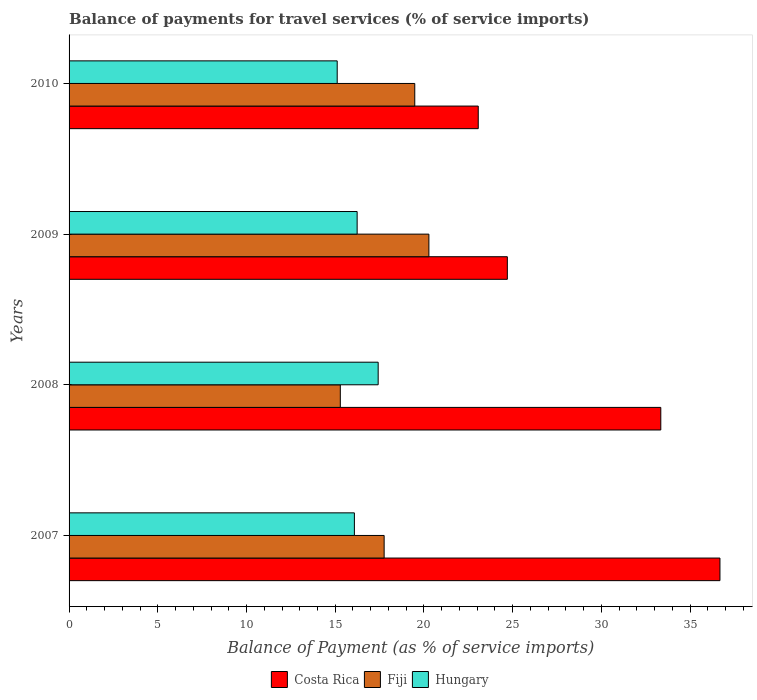How many different coloured bars are there?
Offer a terse response. 3. How many groups of bars are there?
Provide a short and direct response. 4. Are the number of bars per tick equal to the number of legend labels?
Your answer should be compact. Yes. How many bars are there on the 2nd tick from the top?
Make the answer very short. 3. How many bars are there on the 3rd tick from the bottom?
Give a very brief answer. 3. What is the balance of payments for travel services in Hungary in 2007?
Offer a very short reply. 16.08. Across all years, what is the maximum balance of payments for travel services in Fiji?
Ensure brevity in your answer.  20.28. Across all years, what is the minimum balance of payments for travel services in Fiji?
Offer a terse response. 15.29. In which year was the balance of payments for travel services in Fiji maximum?
Offer a terse response. 2009. What is the total balance of payments for travel services in Fiji in the graph?
Offer a very short reply. 72.8. What is the difference between the balance of payments for travel services in Fiji in 2009 and that in 2010?
Your response must be concise. 0.8. What is the difference between the balance of payments for travel services in Hungary in 2009 and the balance of payments for travel services in Costa Rica in 2007?
Make the answer very short. -20.45. What is the average balance of payments for travel services in Costa Rica per year?
Give a very brief answer. 29.45. In the year 2010, what is the difference between the balance of payments for travel services in Hungary and balance of payments for travel services in Fiji?
Your answer should be very brief. -4.37. What is the ratio of the balance of payments for travel services in Costa Rica in 2007 to that in 2010?
Provide a succinct answer. 1.59. Is the balance of payments for travel services in Fiji in 2007 less than that in 2010?
Ensure brevity in your answer.  Yes. Is the difference between the balance of payments for travel services in Hungary in 2008 and 2010 greater than the difference between the balance of payments for travel services in Fiji in 2008 and 2010?
Make the answer very short. Yes. What is the difference between the highest and the second highest balance of payments for travel services in Fiji?
Provide a short and direct response. 0.8. What is the difference between the highest and the lowest balance of payments for travel services in Costa Rica?
Give a very brief answer. 13.62. Is the sum of the balance of payments for travel services in Fiji in 2007 and 2009 greater than the maximum balance of payments for travel services in Hungary across all years?
Provide a succinct answer. Yes. What does the 1st bar from the top in 2008 represents?
Offer a terse response. Hungary. Is it the case that in every year, the sum of the balance of payments for travel services in Fiji and balance of payments for travel services in Hungary is greater than the balance of payments for travel services in Costa Rica?
Keep it short and to the point. No. How many bars are there?
Ensure brevity in your answer.  12. What is the difference between two consecutive major ticks on the X-axis?
Give a very brief answer. 5. Are the values on the major ticks of X-axis written in scientific E-notation?
Offer a terse response. No. Where does the legend appear in the graph?
Offer a very short reply. Bottom center. What is the title of the graph?
Keep it short and to the point. Balance of payments for travel services (% of service imports). What is the label or title of the X-axis?
Your answer should be very brief. Balance of Payment (as % of service imports). What is the label or title of the Y-axis?
Give a very brief answer. Years. What is the Balance of Payment (as % of service imports) of Costa Rica in 2007?
Your answer should be very brief. 36.68. What is the Balance of Payment (as % of service imports) in Fiji in 2007?
Provide a short and direct response. 17.76. What is the Balance of Payment (as % of service imports) in Hungary in 2007?
Offer a terse response. 16.08. What is the Balance of Payment (as % of service imports) in Costa Rica in 2008?
Give a very brief answer. 33.35. What is the Balance of Payment (as % of service imports) in Fiji in 2008?
Keep it short and to the point. 15.29. What is the Balance of Payment (as % of service imports) of Hungary in 2008?
Your answer should be compact. 17.42. What is the Balance of Payment (as % of service imports) in Costa Rica in 2009?
Keep it short and to the point. 24.7. What is the Balance of Payment (as % of service imports) of Fiji in 2009?
Give a very brief answer. 20.28. What is the Balance of Payment (as % of service imports) in Hungary in 2009?
Ensure brevity in your answer.  16.24. What is the Balance of Payment (as % of service imports) in Costa Rica in 2010?
Offer a very short reply. 23.06. What is the Balance of Payment (as % of service imports) in Fiji in 2010?
Your response must be concise. 19.48. What is the Balance of Payment (as % of service imports) of Hungary in 2010?
Provide a succinct answer. 15.11. Across all years, what is the maximum Balance of Payment (as % of service imports) in Costa Rica?
Make the answer very short. 36.68. Across all years, what is the maximum Balance of Payment (as % of service imports) of Fiji?
Keep it short and to the point. 20.28. Across all years, what is the maximum Balance of Payment (as % of service imports) in Hungary?
Your response must be concise. 17.42. Across all years, what is the minimum Balance of Payment (as % of service imports) of Costa Rica?
Provide a succinct answer. 23.06. Across all years, what is the minimum Balance of Payment (as % of service imports) of Fiji?
Provide a succinct answer. 15.29. Across all years, what is the minimum Balance of Payment (as % of service imports) of Hungary?
Ensure brevity in your answer.  15.11. What is the total Balance of Payment (as % of service imports) of Costa Rica in the graph?
Offer a terse response. 117.79. What is the total Balance of Payment (as % of service imports) of Fiji in the graph?
Give a very brief answer. 72.8. What is the total Balance of Payment (as % of service imports) of Hungary in the graph?
Keep it short and to the point. 64.85. What is the difference between the Balance of Payment (as % of service imports) of Costa Rica in 2007 and that in 2008?
Ensure brevity in your answer.  3.33. What is the difference between the Balance of Payment (as % of service imports) in Fiji in 2007 and that in 2008?
Offer a very short reply. 2.47. What is the difference between the Balance of Payment (as % of service imports) of Hungary in 2007 and that in 2008?
Keep it short and to the point. -1.34. What is the difference between the Balance of Payment (as % of service imports) in Costa Rica in 2007 and that in 2009?
Your answer should be compact. 11.98. What is the difference between the Balance of Payment (as % of service imports) of Fiji in 2007 and that in 2009?
Make the answer very short. -2.52. What is the difference between the Balance of Payment (as % of service imports) in Hungary in 2007 and that in 2009?
Offer a very short reply. -0.16. What is the difference between the Balance of Payment (as % of service imports) of Costa Rica in 2007 and that in 2010?
Your answer should be very brief. 13.62. What is the difference between the Balance of Payment (as % of service imports) in Fiji in 2007 and that in 2010?
Provide a succinct answer. -1.73. What is the difference between the Balance of Payment (as % of service imports) in Hungary in 2007 and that in 2010?
Provide a succinct answer. 0.97. What is the difference between the Balance of Payment (as % of service imports) of Costa Rica in 2008 and that in 2009?
Ensure brevity in your answer.  8.65. What is the difference between the Balance of Payment (as % of service imports) in Fiji in 2008 and that in 2009?
Make the answer very short. -4.99. What is the difference between the Balance of Payment (as % of service imports) of Hungary in 2008 and that in 2009?
Your response must be concise. 1.19. What is the difference between the Balance of Payment (as % of service imports) in Costa Rica in 2008 and that in 2010?
Your response must be concise. 10.29. What is the difference between the Balance of Payment (as % of service imports) of Fiji in 2008 and that in 2010?
Make the answer very short. -4.2. What is the difference between the Balance of Payment (as % of service imports) of Hungary in 2008 and that in 2010?
Provide a short and direct response. 2.31. What is the difference between the Balance of Payment (as % of service imports) in Costa Rica in 2009 and that in 2010?
Ensure brevity in your answer.  1.64. What is the difference between the Balance of Payment (as % of service imports) in Fiji in 2009 and that in 2010?
Offer a very short reply. 0.8. What is the difference between the Balance of Payment (as % of service imports) of Hungary in 2009 and that in 2010?
Ensure brevity in your answer.  1.12. What is the difference between the Balance of Payment (as % of service imports) in Costa Rica in 2007 and the Balance of Payment (as % of service imports) in Fiji in 2008?
Give a very brief answer. 21.4. What is the difference between the Balance of Payment (as % of service imports) of Costa Rica in 2007 and the Balance of Payment (as % of service imports) of Hungary in 2008?
Offer a terse response. 19.26. What is the difference between the Balance of Payment (as % of service imports) of Fiji in 2007 and the Balance of Payment (as % of service imports) of Hungary in 2008?
Provide a succinct answer. 0.34. What is the difference between the Balance of Payment (as % of service imports) in Costa Rica in 2007 and the Balance of Payment (as % of service imports) in Fiji in 2009?
Your response must be concise. 16.4. What is the difference between the Balance of Payment (as % of service imports) in Costa Rica in 2007 and the Balance of Payment (as % of service imports) in Hungary in 2009?
Your answer should be compact. 20.45. What is the difference between the Balance of Payment (as % of service imports) of Fiji in 2007 and the Balance of Payment (as % of service imports) of Hungary in 2009?
Make the answer very short. 1.52. What is the difference between the Balance of Payment (as % of service imports) in Costa Rica in 2007 and the Balance of Payment (as % of service imports) in Fiji in 2010?
Provide a succinct answer. 17.2. What is the difference between the Balance of Payment (as % of service imports) in Costa Rica in 2007 and the Balance of Payment (as % of service imports) in Hungary in 2010?
Make the answer very short. 21.57. What is the difference between the Balance of Payment (as % of service imports) in Fiji in 2007 and the Balance of Payment (as % of service imports) in Hungary in 2010?
Your answer should be very brief. 2.65. What is the difference between the Balance of Payment (as % of service imports) of Costa Rica in 2008 and the Balance of Payment (as % of service imports) of Fiji in 2009?
Give a very brief answer. 13.07. What is the difference between the Balance of Payment (as % of service imports) of Costa Rica in 2008 and the Balance of Payment (as % of service imports) of Hungary in 2009?
Keep it short and to the point. 17.11. What is the difference between the Balance of Payment (as % of service imports) of Fiji in 2008 and the Balance of Payment (as % of service imports) of Hungary in 2009?
Your response must be concise. -0.95. What is the difference between the Balance of Payment (as % of service imports) of Costa Rica in 2008 and the Balance of Payment (as % of service imports) of Fiji in 2010?
Offer a terse response. 13.87. What is the difference between the Balance of Payment (as % of service imports) of Costa Rica in 2008 and the Balance of Payment (as % of service imports) of Hungary in 2010?
Keep it short and to the point. 18.24. What is the difference between the Balance of Payment (as % of service imports) of Fiji in 2008 and the Balance of Payment (as % of service imports) of Hungary in 2010?
Keep it short and to the point. 0.18. What is the difference between the Balance of Payment (as % of service imports) of Costa Rica in 2009 and the Balance of Payment (as % of service imports) of Fiji in 2010?
Provide a short and direct response. 5.22. What is the difference between the Balance of Payment (as % of service imports) of Costa Rica in 2009 and the Balance of Payment (as % of service imports) of Hungary in 2010?
Offer a very short reply. 9.59. What is the difference between the Balance of Payment (as % of service imports) in Fiji in 2009 and the Balance of Payment (as % of service imports) in Hungary in 2010?
Keep it short and to the point. 5.17. What is the average Balance of Payment (as % of service imports) of Costa Rica per year?
Give a very brief answer. 29.45. What is the average Balance of Payment (as % of service imports) of Fiji per year?
Offer a very short reply. 18.2. What is the average Balance of Payment (as % of service imports) in Hungary per year?
Ensure brevity in your answer.  16.21. In the year 2007, what is the difference between the Balance of Payment (as % of service imports) of Costa Rica and Balance of Payment (as % of service imports) of Fiji?
Your answer should be very brief. 18.93. In the year 2007, what is the difference between the Balance of Payment (as % of service imports) of Costa Rica and Balance of Payment (as % of service imports) of Hungary?
Provide a succinct answer. 20.6. In the year 2007, what is the difference between the Balance of Payment (as % of service imports) in Fiji and Balance of Payment (as % of service imports) in Hungary?
Provide a succinct answer. 1.68. In the year 2008, what is the difference between the Balance of Payment (as % of service imports) in Costa Rica and Balance of Payment (as % of service imports) in Fiji?
Offer a terse response. 18.06. In the year 2008, what is the difference between the Balance of Payment (as % of service imports) in Costa Rica and Balance of Payment (as % of service imports) in Hungary?
Provide a short and direct response. 15.93. In the year 2008, what is the difference between the Balance of Payment (as % of service imports) in Fiji and Balance of Payment (as % of service imports) in Hungary?
Your answer should be compact. -2.13. In the year 2009, what is the difference between the Balance of Payment (as % of service imports) in Costa Rica and Balance of Payment (as % of service imports) in Fiji?
Ensure brevity in your answer.  4.42. In the year 2009, what is the difference between the Balance of Payment (as % of service imports) of Costa Rica and Balance of Payment (as % of service imports) of Hungary?
Give a very brief answer. 8.47. In the year 2009, what is the difference between the Balance of Payment (as % of service imports) of Fiji and Balance of Payment (as % of service imports) of Hungary?
Offer a terse response. 4.04. In the year 2010, what is the difference between the Balance of Payment (as % of service imports) in Costa Rica and Balance of Payment (as % of service imports) in Fiji?
Provide a succinct answer. 3.58. In the year 2010, what is the difference between the Balance of Payment (as % of service imports) of Costa Rica and Balance of Payment (as % of service imports) of Hungary?
Offer a very short reply. 7.95. In the year 2010, what is the difference between the Balance of Payment (as % of service imports) of Fiji and Balance of Payment (as % of service imports) of Hungary?
Your response must be concise. 4.37. What is the ratio of the Balance of Payment (as % of service imports) of Costa Rica in 2007 to that in 2008?
Keep it short and to the point. 1.1. What is the ratio of the Balance of Payment (as % of service imports) in Fiji in 2007 to that in 2008?
Your answer should be very brief. 1.16. What is the ratio of the Balance of Payment (as % of service imports) of Costa Rica in 2007 to that in 2009?
Offer a very short reply. 1.49. What is the ratio of the Balance of Payment (as % of service imports) of Fiji in 2007 to that in 2009?
Keep it short and to the point. 0.88. What is the ratio of the Balance of Payment (as % of service imports) in Costa Rica in 2007 to that in 2010?
Offer a terse response. 1.59. What is the ratio of the Balance of Payment (as % of service imports) in Fiji in 2007 to that in 2010?
Your answer should be compact. 0.91. What is the ratio of the Balance of Payment (as % of service imports) of Hungary in 2007 to that in 2010?
Keep it short and to the point. 1.06. What is the ratio of the Balance of Payment (as % of service imports) in Costa Rica in 2008 to that in 2009?
Ensure brevity in your answer.  1.35. What is the ratio of the Balance of Payment (as % of service imports) of Fiji in 2008 to that in 2009?
Provide a short and direct response. 0.75. What is the ratio of the Balance of Payment (as % of service imports) in Hungary in 2008 to that in 2009?
Ensure brevity in your answer.  1.07. What is the ratio of the Balance of Payment (as % of service imports) of Costa Rica in 2008 to that in 2010?
Keep it short and to the point. 1.45. What is the ratio of the Balance of Payment (as % of service imports) in Fiji in 2008 to that in 2010?
Provide a short and direct response. 0.78. What is the ratio of the Balance of Payment (as % of service imports) in Hungary in 2008 to that in 2010?
Make the answer very short. 1.15. What is the ratio of the Balance of Payment (as % of service imports) in Costa Rica in 2009 to that in 2010?
Offer a terse response. 1.07. What is the ratio of the Balance of Payment (as % of service imports) of Fiji in 2009 to that in 2010?
Give a very brief answer. 1.04. What is the ratio of the Balance of Payment (as % of service imports) of Hungary in 2009 to that in 2010?
Your response must be concise. 1.07. What is the difference between the highest and the second highest Balance of Payment (as % of service imports) in Costa Rica?
Ensure brevity in your answer.  3.33. What is the difference between the highest and the second highest Balance of Payment (as % of service imports) in Fiji?
Offer a terse response. 0.8. What is the difference between the highest and the second highest Balance of Payment (as % of service imports) of Hungary?
Keep it short and to the point. 1.19. What is the difference between the highest and the lowest Balance of Payment (as % of service imports) of Costa Rica?
Your answer should be compact. 13.62. What is the difference between the highest and the lowest Balance of Payment (as % of service imports) in Fiji?
Ensure brevity in your answer.  4.99. What is the difference between the highest and the lowest Balance of Payment (as % of service imports) of Hungary?
Ensure brevity in your answer.  2.31. 